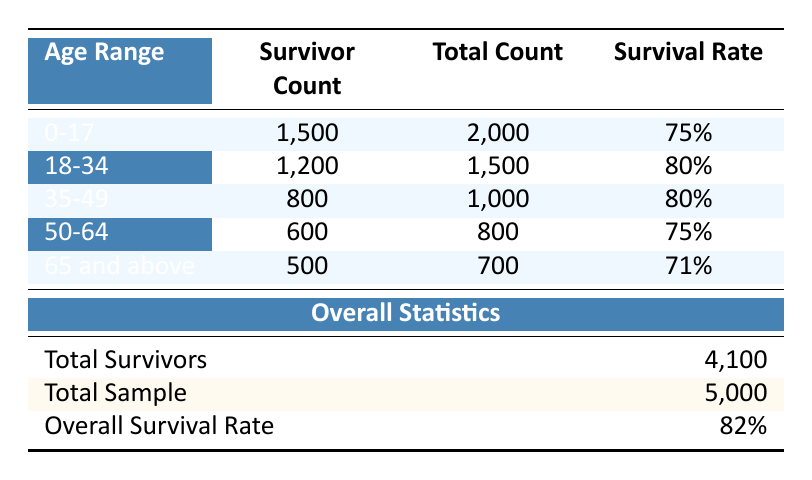What is the survival rate for the age group 0-17? Looking at the table, we can find the row for the age range 0-17, which shows a survival rate of 75%.
Answer: 75% How many survivors are there in the age group 50-64? The table indicates that in the age range of 50-64, there are 600 survivors.
Answer: 600 What is the overall survival rate across all age groups? The "Overall Survival Rate" row at the bottom of the table states that the overall survival rate is 82%.
Answer: 82% Is the survival rate for those aged 65 and above higher than that for the age group 50-64? The survival rate for the age group 65 and above is 71%, while for the age group 50-64, it is 75%. Since 71% is not higher than 75%, the statement is false.
Answer: No What is the total number of survivors from all age groups? By adding the total survivor counts (1500 + 1200 + 800 + 600 + 500 = 4100), we confirm the total number of survivors is 4100.
Answer: 4100 What is the difference in survivor counts between the age groups 18-34 and 35-49? The survivor count for the age group 18-34 is 1200, and for the age group 35-49, it is 800. The difference is 1200 - 800 = 400.
Answer: 400 What percentage of individuals aged 65 and above survived? The survival rate for those aged 65 and above is 71%, as directly stated in the table.
Answer: 71% Which age group has the highest number of survivors? By examining the "Survivor Count" for each age group, the highest count is for the age group 0-17, with 1500 survivors.
Answer: 0-17 